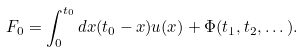<formula> <loc_0><loc_0><loc_500><loc_500>F _ { 0 } = \int _ { 0 } ^ { t _ { 0 } } d x ( t _ { 0 } - x ) u ( x ) + \Phi ( t _ { 1 } , t _ { 2 } , \dots ) .</formula> 